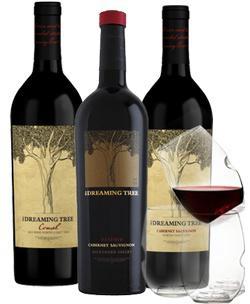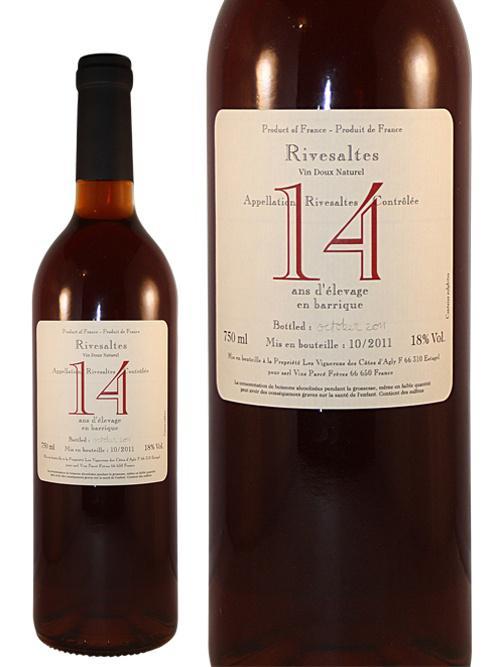The first image is the image on the left, the second image is the image on the right. Given the left and right images, does the statement "There is a wine glass visible on one of the images." hold true? Answer yes or no. Yes. 